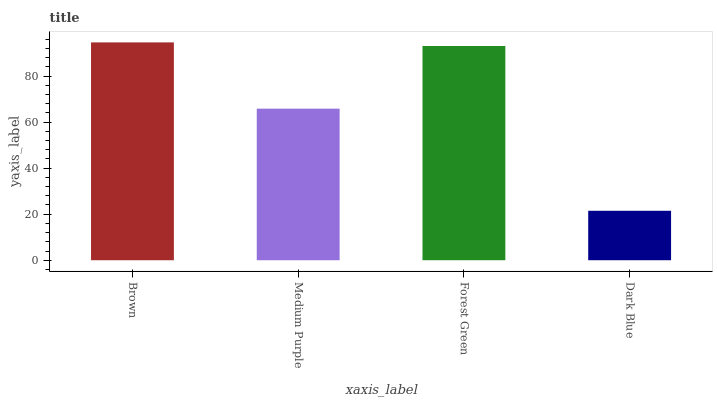Is Brown the maximum?
Answer yes or no. Yes. Is Medium Purple the minimum?
Answer yes or no. No. Is Medium Purple the maximum?
Answer yes or no. No. Is Brown greater than Medium Purple?
Answer yes or no. Yes. Is Medium Purple less than Brown?
Answer yes or no. Yes. Is Medium Purple greater than Brown?
Answer yes or no. No. Is Brown less than Medium Purple?
Answer yes or no. No. Is Forest Green the high median?
Answer yes or no. Yes. Is Medium Purple the low median?
Answer yes or no. Yes. Is Dark Blue the high median?
Answer yes or no. No. Is Brown the low median?
Answer yes or no. No. 